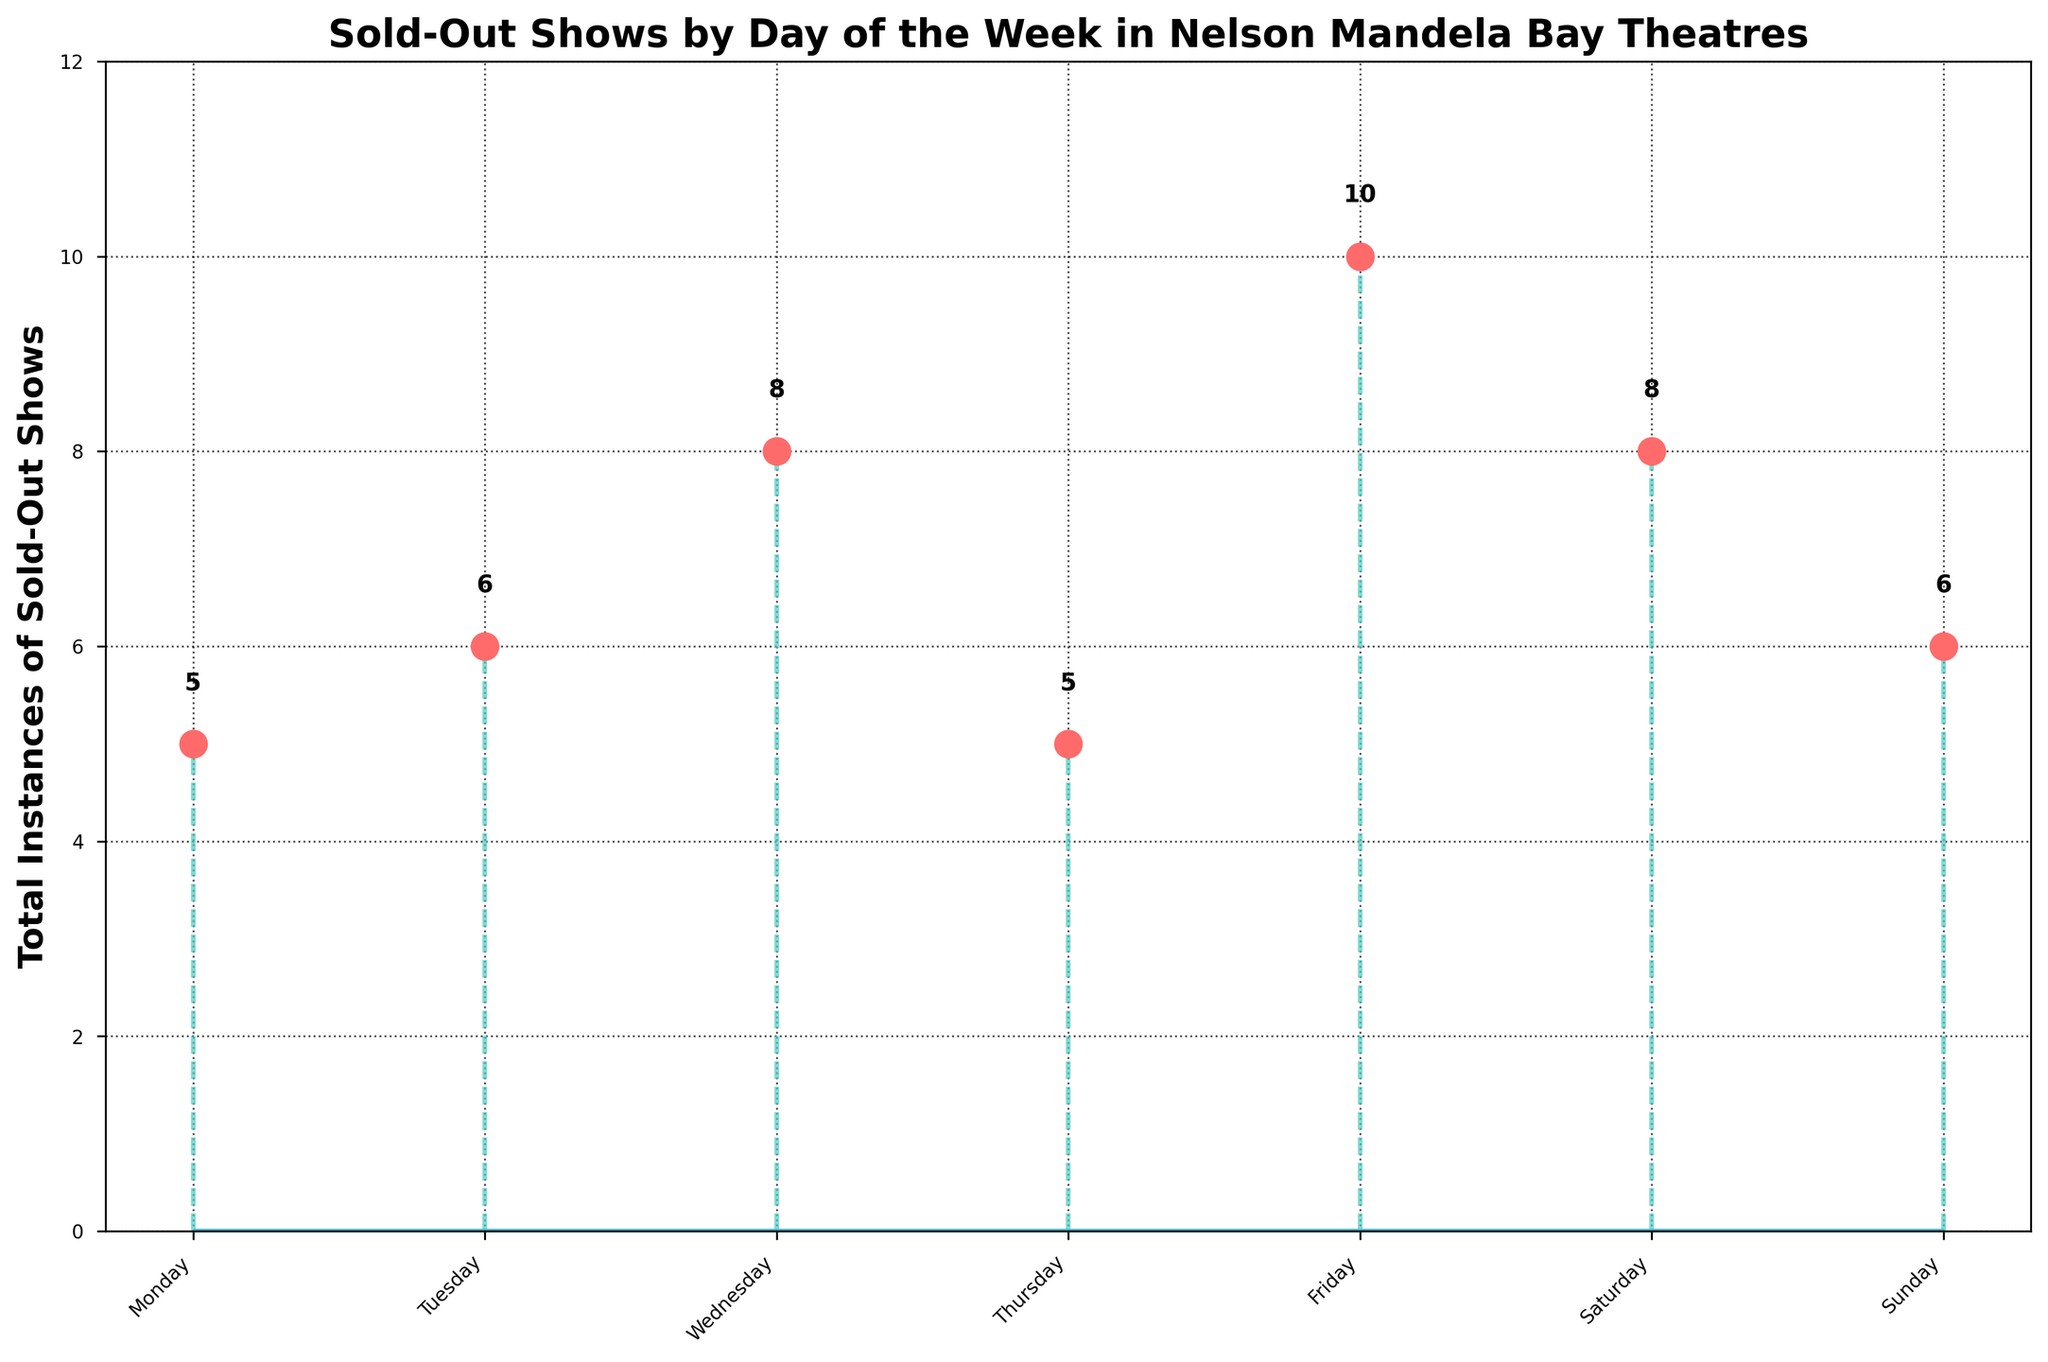What is the title of the figure? The title is found at the top of the figure. It reads "Sold-Out Shows by Day of the Week in Nelson Mandela Bay Theatres".
Answer: "Sold-Out Shows by Day of the Week in Nelson Mandela Bay Theatres" What do the x-axis labels represent? The x-axis labels are the days of the week, shown as Monday, Tuesday, Wednesday, Thursday, Friday, Saturday, and Sunday.
Answer: Days of the week What color are the markers representing sold-out shows? The markers are shown as circles on each stem and are colored bright red.
Answer: Red How many total days are displayed on the x-axis? Count the number of different day labels on the x-axis. There are seven.
Answer: Seven What is the value of the highest data point in the figure? The highest data point is the marker that is above all others on the y-axis, which shows a value of six.
Answer: Six What is the total number of sold-out shows from Thursday to Sunday? Add the values of sold-out shows from Thursday (5), Friday (10), Saturday (8), and Sunday (6). The sum is 5 + 6 + 5 + 6 = 22.
Answer: 22 What is the average number of sold-out shows per day? Sum all the instances (3 + 2 + 6 + 4 + 8 + 5 + 6) giving a total of 34 and then divide by the number of days (7). 34/7 = ~4.86.
Answer: 4.86 What is the difference in the number of sold-out shows between the day with the most and the day with the fewest? The day with the most sold-out shows is Friday (10) and with the fewest is Monday (5). The difference is 10 - 5 = 5.
Answer: 5 Which day has more sold-out shows, Tuesday or Thursday? Compare the values for Tuesday (6) and Thursday (5). Since 6 > 5, Tuesday has more sold-out shows.
Answer: Tuesday Is there any day with an equal number of sold-out shows? Comparing the values for different days, Thursday (5) and Saturday (5) have the same number of sold-out shows.
Answer: Yes, Thursday and Saturday Which day of the week has the least number of sold-out shows and how many are they? Monday has the least number of sold-out shows, with a total value of 5.
Answer: Monday, 5 Why are the stems present in the figure? The stems connect each marker on the x-axis (days of the week) to its corresponding y-axis value (number of sold-out shows), making it easier to visualize the data points along the x and y axes.
Answer: To connect markers to their corresponding y-axis values 